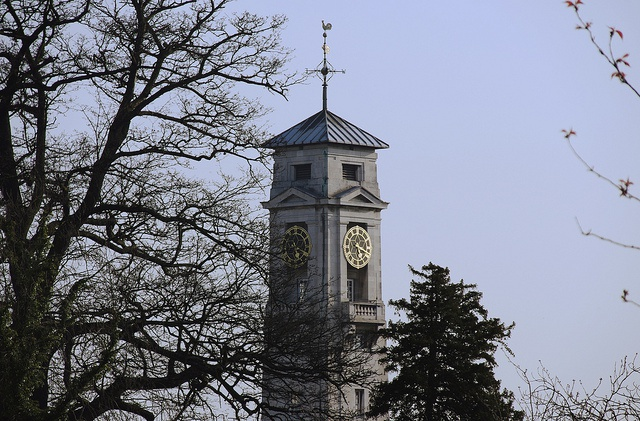Describe the objects in this image and their specific colors. I can see clock in black, darkgreen, and gray tones and clock in black, gray, darkgray, and tan tones in this image. 